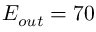Convert formula to latex. <formula><loc_0><loc_0><loc_500><loc_500>E _ { o u t } = 7 0</formula> 